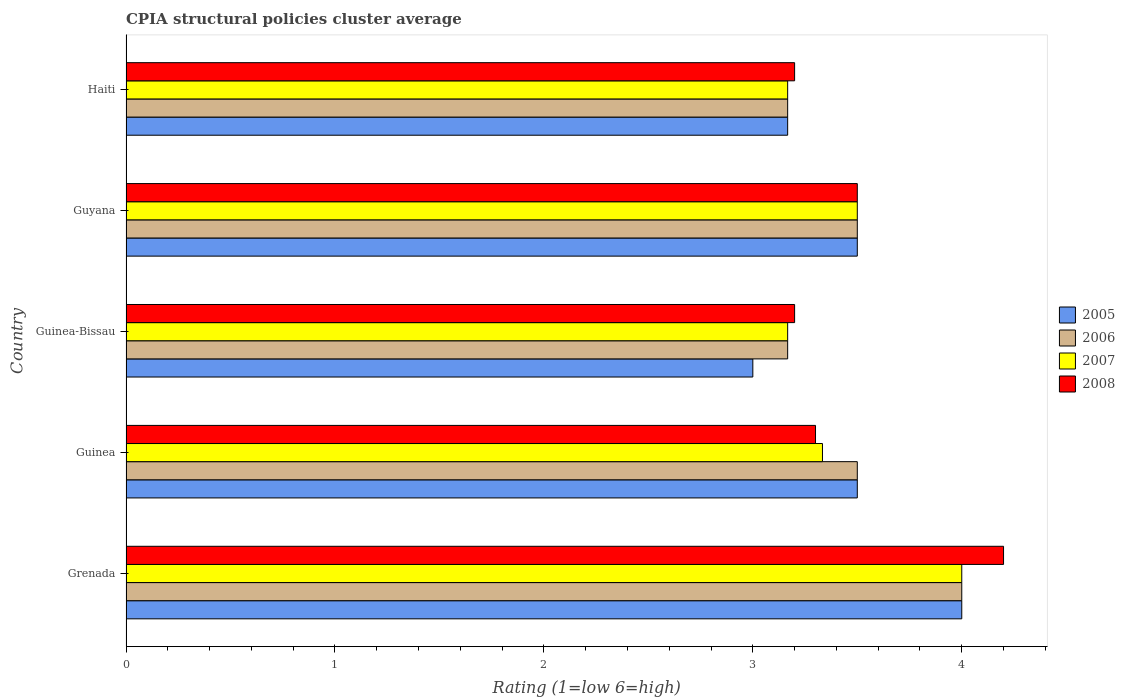How many groups of bars are there?
Your answer should be compact. 5. Are the number of bars on each tick of the Y-axis equal?
Give a very brief answer. Yes. How many bars are there on the 5th tick from the top?
Keep it short and to the point. 4. How many bars are there on the 1st tick from the bottom?
Provide a short and direct response. 4. What is the label of the 5th group of bars from the top?
Keep it short and to the point. Grenada. What is the CPIA rating in 2006 in Guinea-Bissau?
Offer a terse response. 3.17. Across all countries, what is the maximum CPIA rating in 2008?
Keep it short and to the point. 4.2. In which country was the CPIA rating in 2007 maximum?
Give a very brief answer. Grenada. In which country was the CPIA rating in 2006 minimum?
Make the answer very short. Guinea-Bissau. What is the total CPIA rating in 2005 in the graph?
Your answer should be very brief. 17.17. What is the difference between the CPIA rating in 2005 in Guinea-Bissau and that in Haiti?
Offer a terse response. -0.17. What is the difference between the CPIA rating in 2005 in Haiti and the CPIA rating in 2006 in Guinea-Bissau?
Offer a terse response. 0. What is the average CPIA rating in 2005 per country?
Provide a succinct answer. 3.43. What is the difference between the CPIA rating in 2007 and CPIA rating in 2005 in Guinea?
Your answer should be very brief. -0.17. What is the ratio of the CPIA rating in 2005 in Grenada to that in Guyana?
Your response must be concise. 1.14. In how many countries, is the CPIA rating in 2008 greater than the average CPIA rating in 2008 taken over all countries?
Your answer should be very brief. 2. What does the 3rd bar from the top in Guinea represents?
Your answer should be very brief. 2006. What is the difference between two consecutive major ticks on the X-axis?
Your answer should be very brief. 1. Does the graph contain any zero values?
Offer a very short reply. No. Where does the legend appear in the graph?
Offer a terse response. Center right. How many legend labels are there?
Give a very brief answer. 4. How are the legend labels stacked?
Offer a very short reply. Vertical. What is the title of the graph?
Offer a very short reply. CPIA structural policies cluster average. Does "1985" appear as one of the legend labels in the graph?
Keep it short and to the point. No. What is the label or title of the X-axis?
Offer a terse response. Rating (1=low 6=high). What is the Rating (1=low 6=high) of 2005 in Grenada?
Keep it short and to the point. 4. What is the Rating (1=low 6=high) in 2007 in Grenada?
Give a very brief answer. 4. What is the Rating (1=low 6=high) of 2005 in Guinea?
Your response must be concise. 3.5. What is the Rating (1=low 6=high) of 2007 in Guinea?
Provide a short and direct response. 3.33. What is the Rating (1=low 6=high) of 2005 in Guinea-Bissau?
Provide a succinct answer. 3. What is the Rating (1=low 6=high) in 2006 in Guinea-Bissau?
Ensure brevity in your answer.  3.17. What is the Rating (1=low 6=high) in 2007 in Guinea-Bissau?
Your answer should be compact. 3.17. What is the Rating (1=low 6=high) in 2008 in Guinea-Bissau?
Offer a terse response. 3.2. What is the Rating (1=low 6=high) of 2006 in Guyana?
Ensure brevity in your answer.  3.5. What is the Rating (1=low 6=high) of 2007 in Guyana?
Make the answer very short. 3.5. What is the Rating (1=low 6=high) in 2005 in Haiti?
Give a very brief answer. 3.17. What is the Rating (1=low 6=high) of 2006 in Haiti?
Your answer should be very brief. 3.17. What is the Rating (1=low 6=high) of 2007 in Haiti?
Provide a succinct answer. 3.17. Across all countries, what is the maximum Rating (1=low 6=high) in 2005?
Keep it short and to the point. 4. Across all countries, what is the maximum Rating (1=low 6=high) of 2006?
Your answer should be compact. 4. Across all countries, what is the minimum Rating (1=low 6=high) of 2006?
Your answer should be very brief. 3.17. Across all countries, what is the minimum Rating (1=low 6=high) of 2007?
Make the answer very short. 3.17. Across all countries, what is the minimum Rating (1=low 6=high) in 2008?
Your answer should be compact. 3.2. What is the total Rating (1=low 6=high) of 2005 in the graph?
Offer a very short reply. 17.17. What is the total Rating (1=low 6=high) of 2006 in the graph?
Your answer should be very brief. 17.33. What is the total Rating (1=low 6=high) of 2007 in the graph?
Offer a very short reply. 17.17. What is the total Rating (1=low 6=high) of 2008 in the graph?
Your response must be concise. 17.4. What is the difference between the Rating (1=low 6=high) in 2005 in Grenada and that in Guinea?
Your answer should be very brief. 0.5. What is the difference between the Rating (1=low 6=high) of 2006 in Grenada and that in Guinea?
Ensure brevity in your answer.  0.5. What is the difference between the Rating (1=low 6=high) of 2007 in Grenada and that in Guinea?
Make the answer very short. 0.67. What is the difference between the Rating (1=low 6=high) in 2005 in Grenada and that in Guyana?
Ensure brevity in your answer.  0.5. What is the difference between the Rating (1=low 6=high) in 2008 in Grenada and that in Guyana?
Give a very brief answer. 0.7. What is the difference between the Rating (1=low 6=high) in 2007 in Grenada and that in Haiti?
Offer a terse response. 0.83. What is the difference between the Rating (1=low 6=high) of 2008 in Grenada and that in Haiti?
Provide a succinct answer. 1. What is the difference between the Rating (1=low 6=high) of 2005 in Guinea and that in Guinea-Bissau?
Provide a short and direct response. 0.5. What is the difference between the Rating (1=low 6=high) in 2008 in Guinea and that in Guinea-Bissau?
Provide a short and direct response. 0.1. What is the difference between the Rating (1=low 6=high) in 2005 in Guinea and that in Guyana?
Make the answer very short. 0. What is the difference between the Rating (1=low 6=high) of 2008 in Guinea and that in Guyana?
Offer a terse response. -0.2. What is the difference between the Rating (1=low 6=high) of 2008 in Guinea and that in Haiti?
Your answer should be very brief. 0.1. What is the difference between the Rating (1=low 6=high) in 2008 in Guinea-Bissau and that in Haiti?
Give a very brief answer. 0. What is the difference between the Rating (1=low 6=high) of 2005 in Guyana and that in Haiti?
Keep it short and to the point. 0.33. What is the difference between the Rating (1=low 6=high) in 2007 in Guyana and that in Haiti?
Your answer should be compact. 0.33. What is the difference between the Rating (1=low 6=high) of 2005 in Grenada and the Rating (1=low 6=high) of 2006 in Guinea?
Offer a terse response. 0.5. What is the difference between the Rating (1=low 6=high) in 2005 in Grenada and the Rating (1=low 6=high) in 2007 in Guinea?
Offer a terse response. 0.67. What is the difference between the Rating (1=low 6=high) in 2006 in Grenada and the Rating (1=low 6=high) in 2007 in Guinea?
Offer a very short reply. 0.67. What is the difference between the Rating (1=low 6=high) in 2006 in Grenada and the Rating (1=low 6=high) in 2008 in Guinea?
Your answer should be very brief. 0.7. What is the difference between the Rating (1=low 6=high) of 2005 in Grenada and the Rating (1=low 6=high) of 2008 in Guinea-Bissau?
Keep it short and to the point. 0.8. What is the difference between the Rating (1=low 6=high) of 2006 in Grenada and the Rating (1=low 6=high) of 2008 in Guinea-Bissau?
Provide a short and direct response. 0.8. What is the difference between the Rating (1=low 6=high) of 2007 in Grenada and the Rating (1=low 6=high) of 2008 in Guinea-Bissau?
Offer a very short reply. 0.8. What is the difference between the Rating (1=low 6=high) in 2005 in Grenada and the Rating (1=low 6=high) in 2007 in Guyana?
Ensure brevity in your answer.  0.5. What is the difference between the Rating (1=low 6=high) in 2006 in Grenada and the Rating (1=low 6=high) in 2007 in Guyana?
Provide a succinct answer. 0.5. What is the difference between the Rating (1=low 6=high) in 2006 in Grenada and the Rating (1=low 6=high) in 2008 in Guyana?
Your answer should be very brief. 0.5. What is the difference between the Rating (1=low 6=high) in 2007 in Grenada and the Rating (1=low 6=high) in 2008 in Guyana?
Provide a short and direct response. 0.5. What is the difference between the Rating (1=low 6=high) of 2005 in Grenada and the Rating (1=low 6=high) of 2006 in Haiti?
Keep it short and to the point. 0.83. What is the difference between the Rating (1=low 6=high) of 2005 in Grenada and the Rating (1=low 6=high) of 2007 in Haiti?
Give a very brief answer. 0.83. What is the difference between the Rating (1=low 6=high) in 2006 in Grenada and the Rating (1=low 6=high) in 2007 in Haiti?
Provide a short and direct response. 0.83. What is the difference between the Rating (1=low 6=high) of 2006 in Grenada and the Rating (1=low 6=high) of 2008 in Haiti?
Your answer should be very brief. 0.8. What is the difference between the Rating (1=low 6=high) in 2005 in Guinea and the Rating (1=low 6=high) in 2006 in Guinea-Bissau?
Give a very brief answer. 0.33. What is the difference between the Rating (1=low 6=high) of 2005 in Guinea and the Rating (1=low 6=high) of 2007 in Guinea-Bissau?
Make the answer very short. 0.33. What is the difference between the Rating (1=low 6=high) in 2006 in Guinea and the Rating (1=low 6=high) in 2007 in Guinea-Bissau?
Your answer should be very brief. 0.33. What is the difference between the Rating (1=low 6=high) of 2007 in Guinea and the Rating (1=low 6=high) of 2008 in Guinea-Bissau?
Your answer should be compact. 0.13. What is the difference between the Rating (1=low 6=high) of 2005 in Guinea and the Rating (1=low 6=high) of 2008 in Guyana?
Your answer should be very brief. 0. What is the difference between the Rating (1=low 6=high) of 2007 in Guinea and the Rating (1=low 6=high) of 2008 in Guyana?
Give a very brief answer. -0.17. What is the difference between the Rating (1=low 6=high) in 2005 in Guinea and the Rating (1=low 6=high) in 2007 in Haiti?
Offer a very short reply. 0.33. What is the difference between the Rating (1=low 6=high) in 2005 in Guinea and the Rating (1=low 6=high) in 2008 in Haiti?
Your answer should be very brief. 0.3. What is the difference between the Rating (1=low 6=high) of 2006 in Guinea and the Rating (1=low 6=high) of 2007 in Haiti?
Offer a very short reply. 0.33. What is the difference between the Rating (1=low 6=high) of 2006 in Guinea and the Rating (1=low 6=high) of 2008 in Haiti?
Give a very brief answer. 0.3. What is the difference between the Rating (1=low 6=high) in 2007 in Guinea and the Rating (1=low 6=high) in 2008 in Haiti?
Keep it short and to the point. 0.13. What is the difference between the Rating (1=low 6=high) of 2005 in Guinea-Bissau and the Rating (1=low 6=high) of 2007 in Guyana?
Keep it short and to the point. -0.5. What is the difference between the Rating (1=low 6=high) of 2005 in Guinea-Bissau and the Rating (1=low 6=high) of 2008 in Guyana?
Ensure brevity in your answer.  -0.5. What is the difference between the Rating (1=low 6=high) of 2006 in Guinea-Bissau and the Rating (1=low 6=high) of 2007 in Guyana?
Give a very brief answer. -0.33. What is the difference between the Rating (1=low 6=high) of 2006 in Guinea-Bissau and the Rating (1=low 6=high) of 2008 in Guyana?
Provide a short and direct response. -0.33. What is the difference between the Rating (1=low 6=high) of 2007 in Guinea-Bissau and the Rating (1=low 6=high) of 2008 in Guyana?
Ensure brevity in your answer.  -0.33. What is the difference between the Rating (1=low 6=high) of 2005 in Guinea-Bissau and the Rating (1=low 6=high) of 2006 in Haiti?
Your answer should be very brief. -0.17. What is the difference between the Rating (1=low 6=high) in 2005 in Guinea-Bissau and the Rating (1=low 6=high) in 2007 in Haiti?
Your answer should be very brief. -0.17. What is the difference between the Rating (1=low 6=high) of 2006 in Guinea-Bissau and the Rating (1=low 6=high) of 2008 in Haiti?
Provide a succinct answer. -0.03. What is the difference between the Rating (1=low 6=high) of 2007 in Guinea-Bissau and the Rating (1=low 6=high) of 2008 in Haiti?
Offer a very short reply. -0.03. What is the difference between the Rating (1=low 6=high) in 2005 in Guyana and the Rating (1=low 6=high) in 2006 in Haiti?
Make the answer very short. 0.33. What is the difference between the Rating (1=low 6=high) in 2005 in Guyana and the Rating (1=low 6=high) in 2007 in Haiti?
Provide a succinct answer. 0.33. What is the difference between the Rating (1=low 6=high) in 2007 in Guyana and the Rating (1=low 6=high) in 2008 in Haiti?
Provide a short and direct response. 0.3. What is the average Rating (1=low 6=high) of 2005 per country?
Offer a very short reply. 3.43. What is the average Rating (1=low 6=high) of 2006 per country?
Your answer should be compact. 3.47. What is the average Rating (1=low 6=high) of 2007 per country?
Provide a succinct answer. 3.43. What is the average Rating (1=low 6=high) of 2008 per country?
Give a very brief answer. 3.48. What is the difference between the Rating (1=low 6=high) of 2005 and Rating (1=low 6=high) of 2006 in Grenada?
Your answer should be compact. 0. What is the difference between the Rating (1=low 6=high) in 2005 and Rating (1=low 6=high) in 2008 in Grenada?
Ensure brevity in your answer.  -0.2. What is the difference between the Rating (1=low 6=high) of 2005 and Rating (1=low 6=high) of 2008 in Guinea?
Ensure brevity in your answer.  0.2. What is the difference between the Rating (1=low 6=high) in 2006 and Rating (1=low 6=high) in 2007 in Guinea?
Your answer should be very brief. 0.17. What is the difference between the Rating (1=low 6=high) in 2007 and Rating (1=low 6=high) in 2008 in Guinea?
Your answer should be very brief. 0.03. What is the difference between the Rating (1=low 6=high) of 2006 and Rating (1=low 6=high) of 2008 in Guinea-Bissau?
Make the answer very short. -0.03. What is the difference between the Rating (1=low 6=high) of 2007 and Rating (1=low 6=high) of 2008 in Guinea-Bissau?
Give a very brief answer. -0.03. What is the difference between the Rating (1=low 6=high) in 2005 and Rating (1=low 6=high) in 2006 in Guyana?
Make the answer very short. 0. What is the difference between the Rating (1=low 6=high) in 2006 and Rating (1=low 6=high) in 2007 in Guyana?
Give a very brief answer. 0. What is the difference between the Rating (1=low 6=high) in 2006 and Rating (1=low 6=high) in 2008 in Guyana?
Keep it short and to the point. 0. What is the difference between the Rating (1=low 6=high) in 2007 and Rating (1=low 6=high) in 2008 in Guyana?
Ensure brevity in your answer.  0. What is the difference between the Rating (1=low 6=high) in 2005 and Rating (1=low 6=high) in 2007 in Haiti?
Keep it short and to the point. 0. What is the difference between the Rating (1=low 6=high) of 2005 and Rating (1=low 6=high) of 2008 in Haiti?
Your answer should be compact. -0.03. What is the difference between the Rating (1=low 6=high) of 2006 and Rating (1=low 6=high) of 2007 in Haiti?
Your response must be concise. 0. What is the difference between the Rating (1=low 6=high) in 2006 and Rating (1=low 6=high) in 2008 in Haiti?
Keep it short and to the point. -0.03. What is the difference between the Rating (1=low 6=high) of 2007 and Rating (1=low 6=high) of 2008 in Haiti?
Keep it short and to the point. -0.03. What is the ratio of the Rating (1=low 6=high) of 2005 in Grenada to that in Guinea?
Make the answer very short. 1.14. What is the ratio of the Rating (1=low 6=high) in 2006 in Grenada to that in Guinea?
Keep it short and to the point. 1.14. What is the ratio of the Rating (1=low 6=high) in 2008 in Grenada to that in Guinea?
Offer a terse response. 1.27. What is the ratio of the Rating (1=low 6=high) in 2005 in Grenada to that in Guinea-Bissau?
Your response must be concise. 1.33. What is the ratio of the Rating (1=low 6=high) in 2006 in Grenada to that in Guinea-Bissau?
Provide a succinct answer. 1.26. What is the ratio of the Rating (1=low 6=high) in 2007 in Grenada to that in Guinea-Bissau?
Your response must be concise. 1.26. What is the ratio of the Rating (1=low 6=high) in 2008 in Grenada to that in Guinea-Bissau?
Offer a terse response. 1.31. What is the ratio of the Rating (1=low 6=high) in 2007 in Grenada to that in Guyana?
Your answer should be compact. 1.14. What is the ratio of the Rating (1=low 6=high) in 2008 in Grenada to that in Guyana?
Make the answer very short. 1.2. What is the ratio of the Rating (1=low 6=high) of 2005 in Grenada to that in Haiti?
Ensure brevity in your answer.  1.26. What is the ratio of the Rating (1=low 6=high) in 2006 in Grenada to that in Haiti?
Ensure brevity in your answer.  1.26. What is the ratio of the Rating (1=low 6=high) in 2007 in Grenada to that in Haiti?
Provide a short and direct response. 1.26. What is the ratio of the Rating (1=low 6=high) of 2008 in Grenada to that in Haiti?
Offer a very short reply. 1.31. What is the ratio of the Rating (1=low 6=high) of 2006 in Guinea to that in Guinea-Bissau?
Offer a terse response. 1.11. What is the ratio of the Rating (1=low 6=high) in 2007 in Guinea to that in Guinea-Bissau?
Offer a very short reply. 1.05. What is the ratio of the Rating (1=low 6=high) of 2008 in Guinea to that in Guinea-Bissau?
Keep it short and to the point. 1.03. What is the ratio of the Rating (1=low 6=high) of 2005 in Guinea to that in Guyana?
Your response must be concise. 1. What is the ratio of the Rating (1=low 6=high) of 2006 in Guinea to that in Guyana?
Your answer should be very brief. 1. What is the ratio of the Rating (1=low 6=high) of 2008 in Guinea to that in Guyana?
Provide a short and direct response. 0.94. What is the ratio of the Rating (1=low 6=high) in 2005 in Guinea to that in Haiti?
Offer a terse response. 1.11. What is the ratio of the Rating (1=low 6=high) of 2006 in Guinea to that in Haiti?
Your response must be concise. 1.11. What is the ratio of the Rating (1=low 6=high) of 2007 in Guinea to that in Haiti?
Provide a succinct answer. 1.05. What is the ratio of the Rating (1=low 6=high) in 2008 in Guinea to that in Haiti?
Provide a succinct answer. 1.03. What is the ratio of the Rating (1=low 6=high) of 2006 in Guinea-Bissau to that in Guyana?
Provide a succinct answer. 0.9. What is the ratio of the Rating (1=low 6=high) in 2007 in Guinea-Bissau to that in Guyana?
Your answer should be compact. 0.9. What is the ratio of the Rating (1=low 6=high) of 2008 in Guinea-Bissau to that in Guyana?
Give a very brief answer. 0.91. What is the ratio of the Rating (1=low 6=high) in 2005 in Guinea-Bissau to that in Haiti?
Offer a terse response. 0.95. What is the ratio of the Rating (1=low 6=high) of 2005 in Guyana to that in Haiti?
Provide a short and direct response. 1.11. What is the ratio of the Rating (1=low 6=high) in 2006 in Guyana to that in Haiti?
Give a very brief answer. 1.11. What is the ratio of the Rating (1=low 6=high) in 2007 in Guyana to that in Haiti?
Provide a succinct answer. 1.11. What is the ratio of the Rating (1=low 6=high) of 2008 in Guyana to that in Haiti?
Provide a succinct answer. 1.09. What is the difference between the highest and the second highest Rating (1=low 6=high) in 2006?
Make the answer very short. 0.5. What is the difference between the highest and the lowest Rating (1=low 6=high) in 2005?
Give a very brief answer. 1. What is the difference between the highest and the lowest Rating (1=low 6=high) in 2006?
Make the answer very short. 0.83. What is the difference between the highest and the lowest Rating (1=low 6=high) of 2007?
Your answer should be compact. 0.83. What is the difference between the highest and the lowest Rating (1=low 6=high) in 2008?
Make the answer very short. 1. 